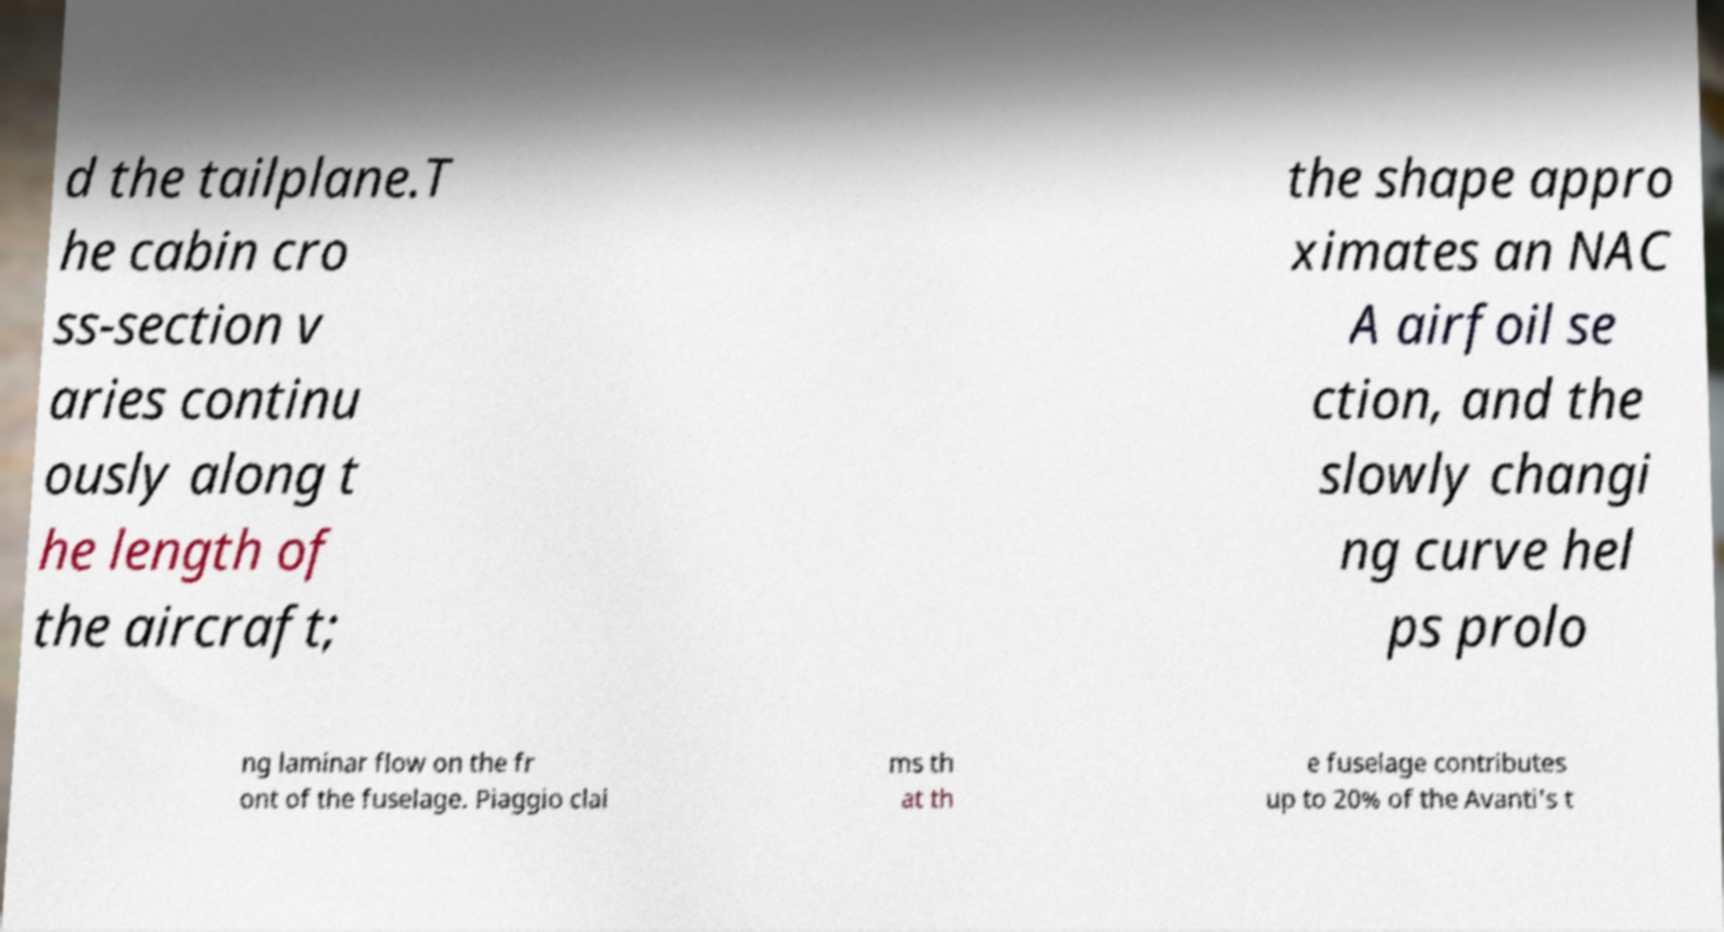What messages or text are displayed in this image? I need them in a readable, typed format. d the tailplane.T he cabin cro ss-section v aries continu ously along t he length of the aircraft; the shape appro ximates an NAC A airfoil se ction, and the slowly changi ng curve hel ps prolo ng laminar flow on the fr ont of the fuselage. Piaggio clai ms th at th e fuselage contributes up to 20% of the Avanti's t 